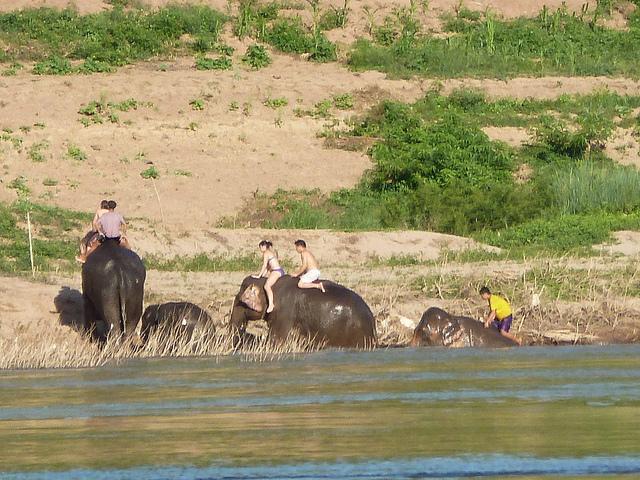How many elephants are there?
Give a very brief answer. 3. How many sinks are to the right of the shower?
Give a very brief answer. 0. 